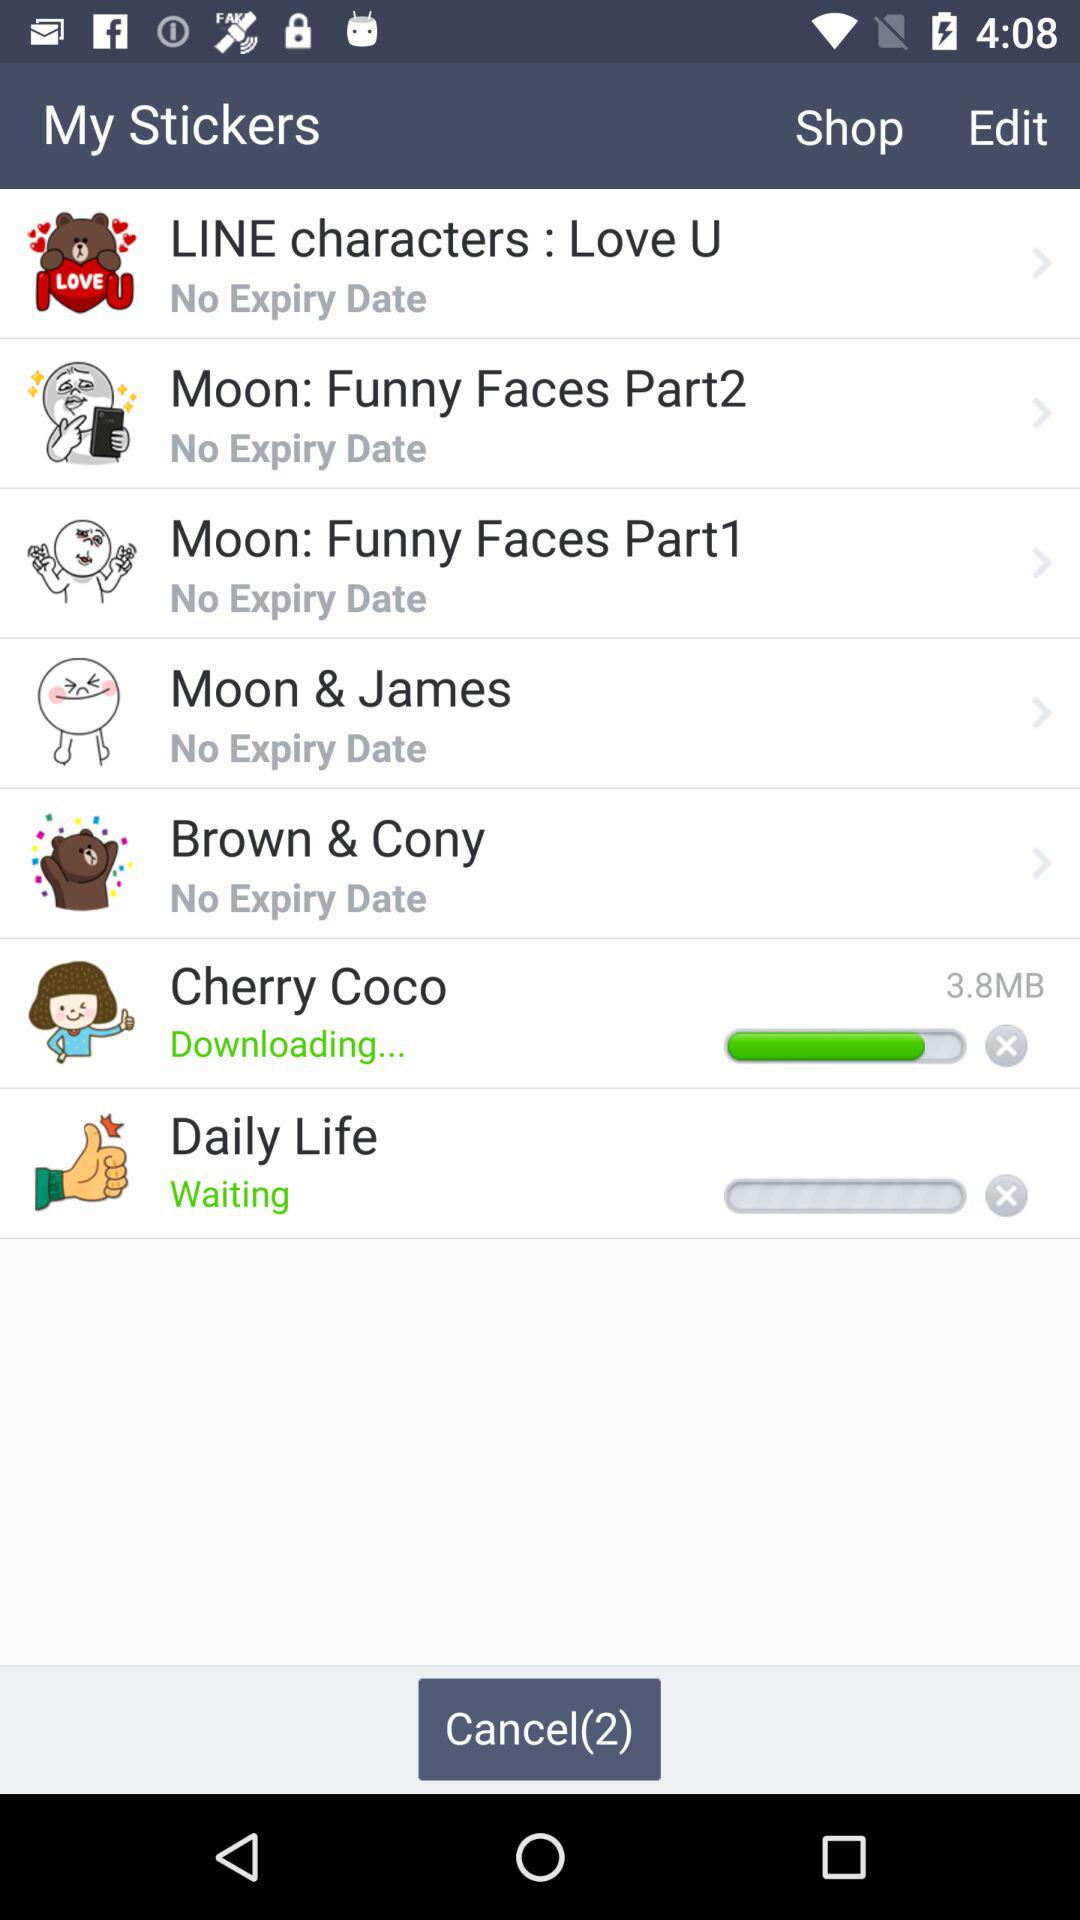Which sticker is currently downloading? The currently downloading sticker is "Cherry Coco". 